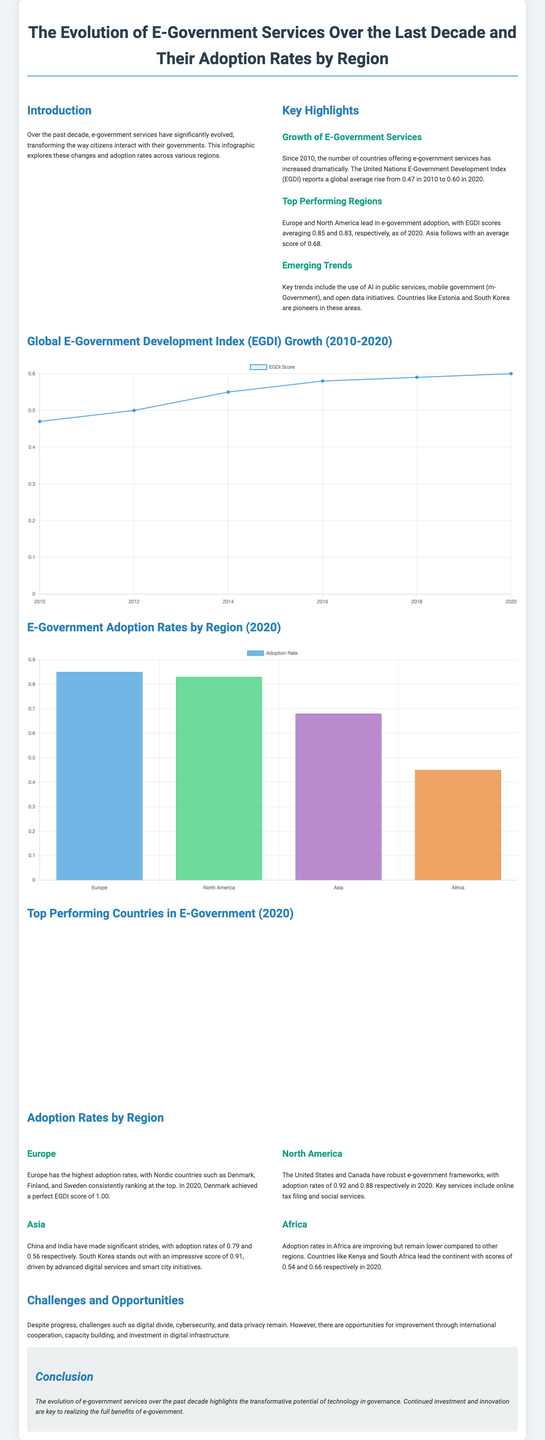What was the global average EGDI score in 2010? The document states that the global average EGDI score in 2010 was reported as 0.47.
Answer: 0.47 Which region had the highest e-government adoption rate in 2020? According to the infographic, Europe had the highest adoption rate with an average of 0.85.
Answer: Europe What is the EGDI score of Denmark in 2020? The text mentions that Denmark achieved a perfect EGDI score of 1.00 in 2020.
Answer: 1.00 What trend involves the use of AI in public services? The document highlights the use of AI in public services as one of the emerging trends in e-government.
Answer: AI in public services What were the EGDI scores for North America in 2020? The infographic states that North America had EGDI scores of 0.83 in 2020.
Answer: 0.83 Which country is mentioned as a pioneer in open data initiatives? The document indicates that countries like Estonia and South Korea are pioneers in open data initiatives.
Answer: Estonia and South Korea What is the adoption rate in Africa according to the document? The document presents that the adoption rates in Africa are improving but remain lower, with Kenya and South Africa leading at 0.54 and 0.66.
Answer: 0.54 and 0.66 What is the main challenge mentioned regarding e-government services? The infographic refers to challenges such as the digital divide, cybersecurity, and data privacy.
Answer: Digital divide How is the EGDI growth displayed in the document? The growth of the EGDI is displayed in the document using a line chart from 2010 to 2020.
Answer: Line chart 